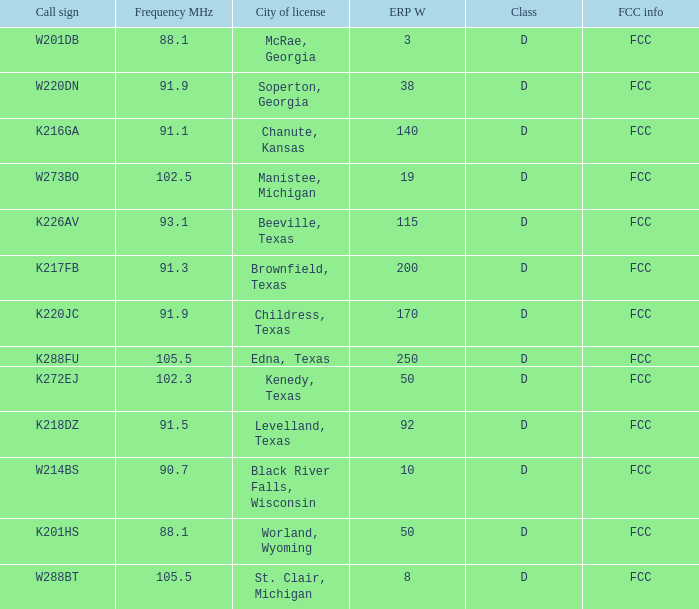When the frequency mhz is below 102.5, what is the city of license? McRae, Georgia, Soperton, Georgia, Chanute, Kansas, Beeville, Texas, Brownfield, Texas, Childress, Texas, Kenedy, Texas, Levelland, Texas, Black River Falls, Wisconsin, Worland, Wyoming. 